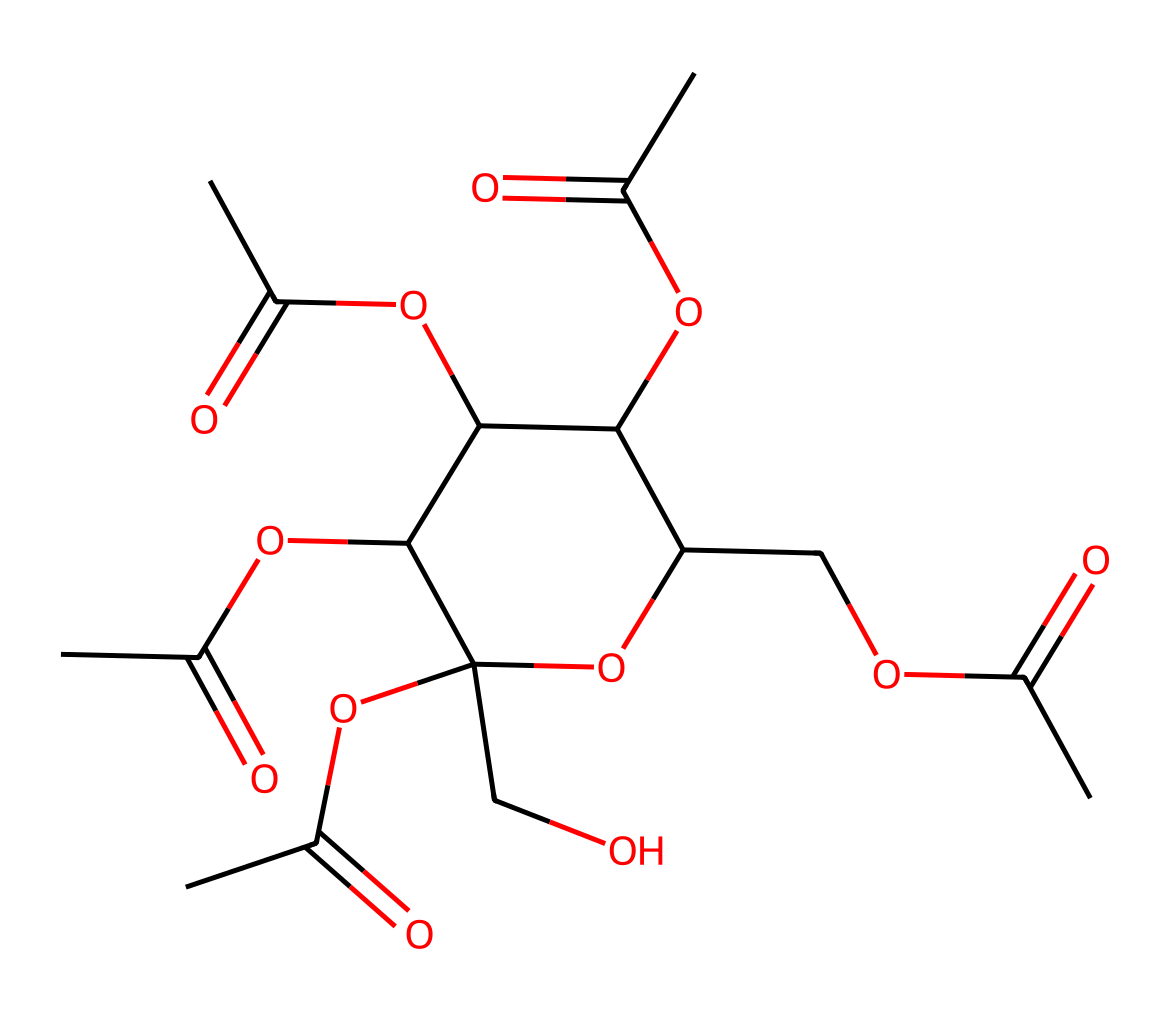What is the main functional group present in cellulose acetate? The primary functional group in cellulose acetate is an ester group, which is evident from the acetate functional groups (–C(=O)O–) present in its structure.
Answer: ester How many carbon atoms are in the structure of cellulose acetate? By analyzing the SMILES representation, we can count the number of carbon atoms. There are a total of 12 carbon atoms derived from the multiple carbon-containing groups included in the structure.
Answer: 12 What type of polymer is cellulose acetate classified as? Cellulose acetate is classified as a thermoplastic polymer due to its ability to soften upon heating and its capability to be reshaped.
Answer: thermoplastic How many hydroxyl groups are present in the cellulose acetate structure? The structure can be examined to identify hydroxyl groups, which are indicated by –OH. Cellulose acetate contains 4 hydroxyl groups.
Answer: 4 What would be the degree of substitution of cellulose acetate? The degree of substitution in cellulose acetate is usually around 2.5 to 3, indicating that on average, 2.5 to 3 hydroxyl groups on the cellulose molecule are replaced by acetate groups.
Answer: 2.5 to 3 What process is used to create cellulose acetate from cellulose? Cellulose acetate is produced through the acetylation process of cellulose, where cellulose reacts with acetic anhydride or acetic acid to form the acetate.
Answer: acetylation 